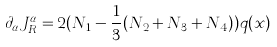Convert formula to latex. <formula><loc_0><loc_0><loc_500><loc_500>\partial _ { \alpha } J _ { R } ^ { \alpha } = 2 ( N _ { 1 } - \frac { 1 } { 3 } ( N _ { 2 } + N _ { 3 } + N _ { 4 } ) ) q ( x )</formula> 